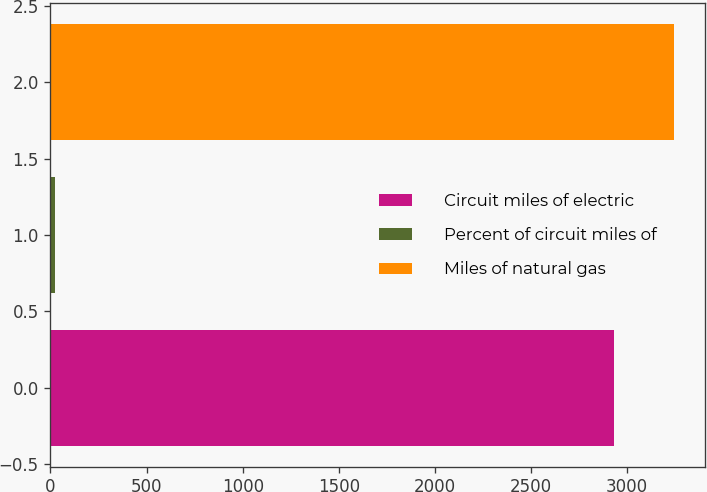Convert chart to OTSL. <chart><loc_0><loc_0><loc_500><loc_500><bar_chart><fcel>Circuit miles of electric<fcel>Percent of circuit miles of<fcel>Miles of natural gas<nl><fcel>2931<fcel>21<fcel>3243.4<nl></chart> 